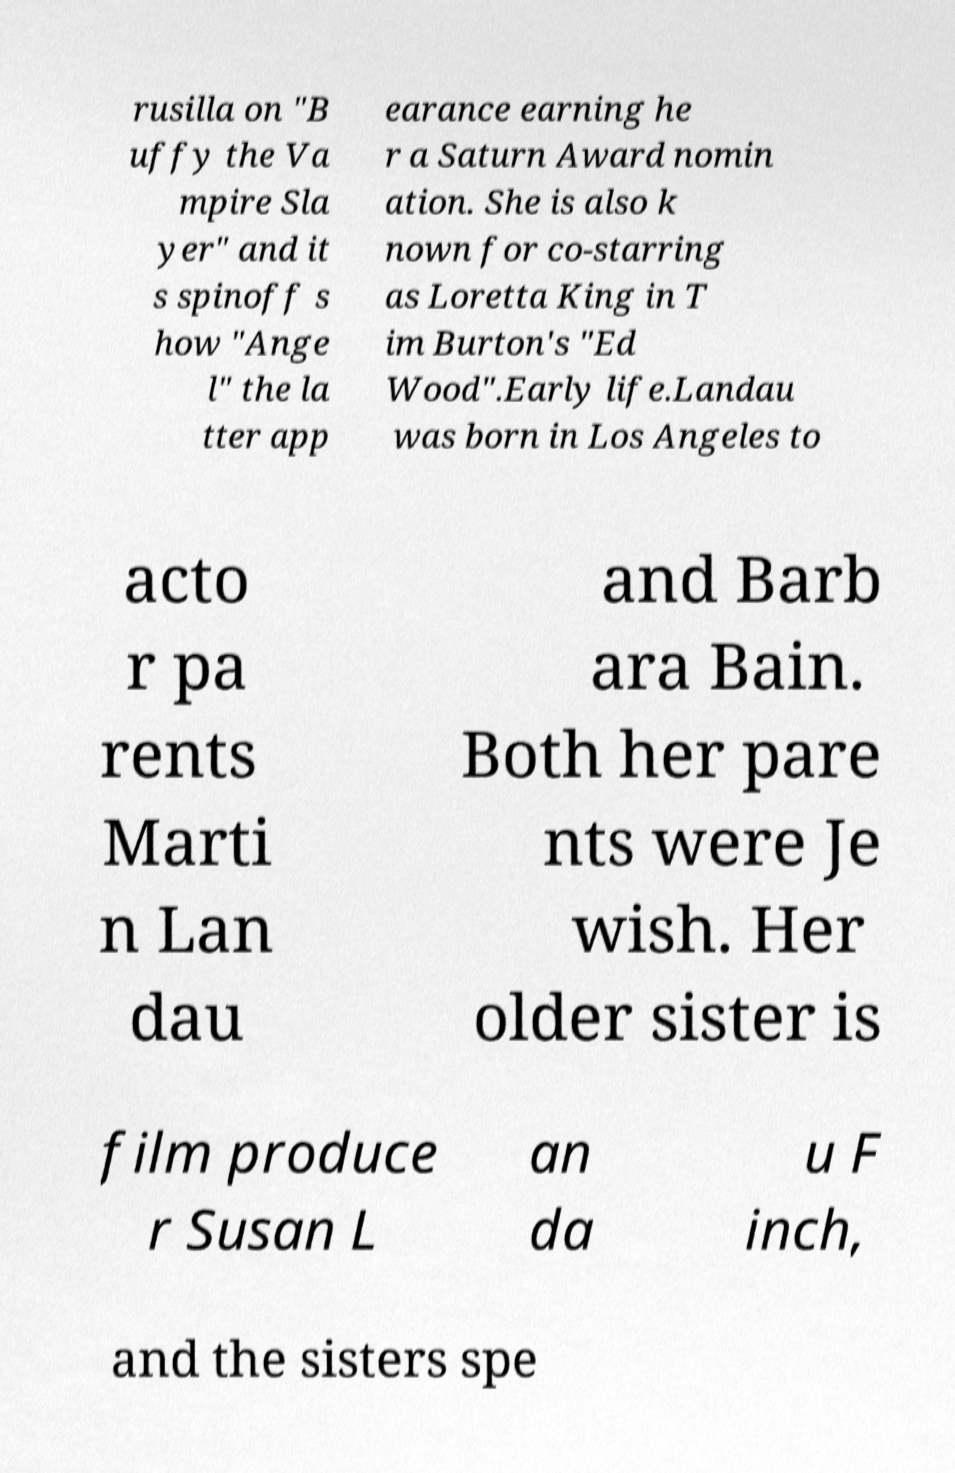Could you extract and type out the text from this image? rusilla on "B uffy the Va mpire Sla yer" and it s spinoff s how "Ange l" the la tter app earance earning he r a Saturn Award nomin ation. She is also k nown for co-starring as Loretta King in T im Burton's "Ed Wood".Early life.Landau was born in Los Angeles to acto r pa rents Marti n Lan dau and Barb ara Bain. Both her pare nts were Je wish. Her older sister is film produce r Susan L an da u F inch, and the sisters spe 